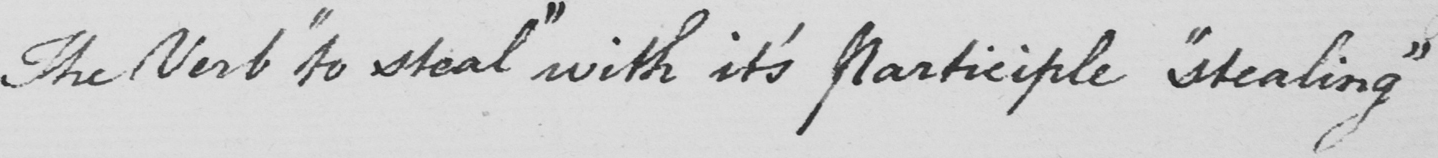Can you read and transcribe this handwriting? The Verb  " to steal "  with it ' s Participle  " stealing " 